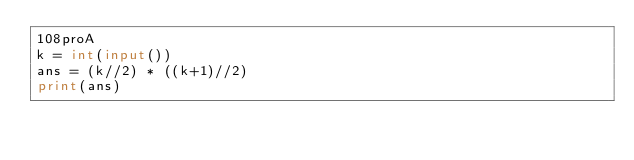<code> <loc_0><loc_0><loc_500><loc_500><_Python_>108proA
k = int(input())
ans = (k//2) * ((k+1)//2)
print(ans)</code> 